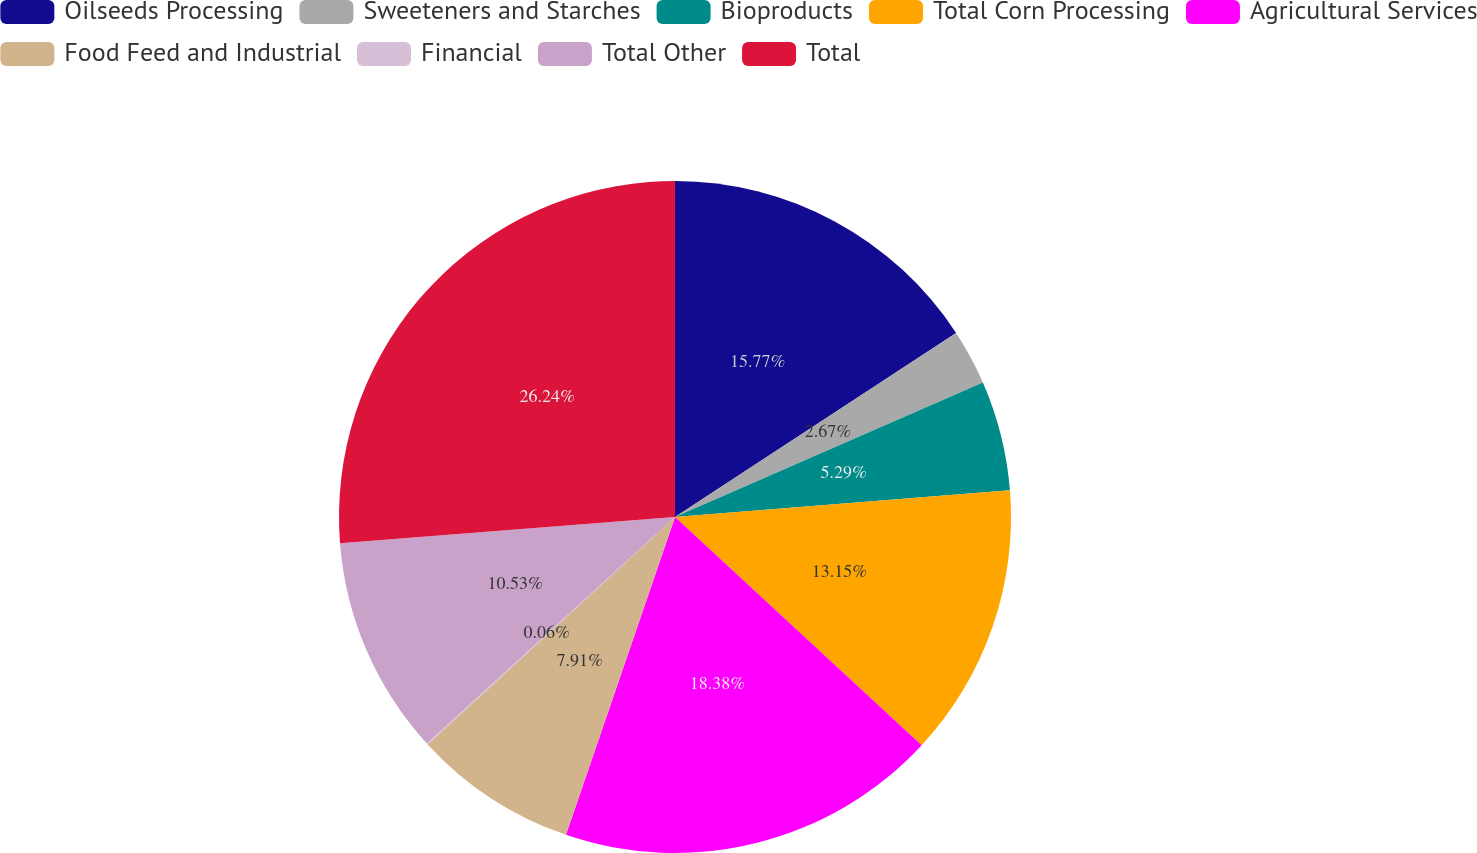Convert chart to OTSL. <chart><loc_0><loc_0><loc_500><loc_500><pie_chart><fcel>Oilseeds Processing<fcel>Sweeteners and Starches<fcel>Bioproducts<fcel>Total Corn Processing<fcel>Agricultural Services<fcel>Food Feed and Industrial<fcel>Financial<fcel>Total Other<fcel>Total<nl><fcel>15.77%<fcel>2.67%<fcel>5.29%<fcel>13.15%<fcel>18.38%<fcel>7.91%<fcel>0.06%<fcel>10.53%<fcel>26.24%<nl></chart> 